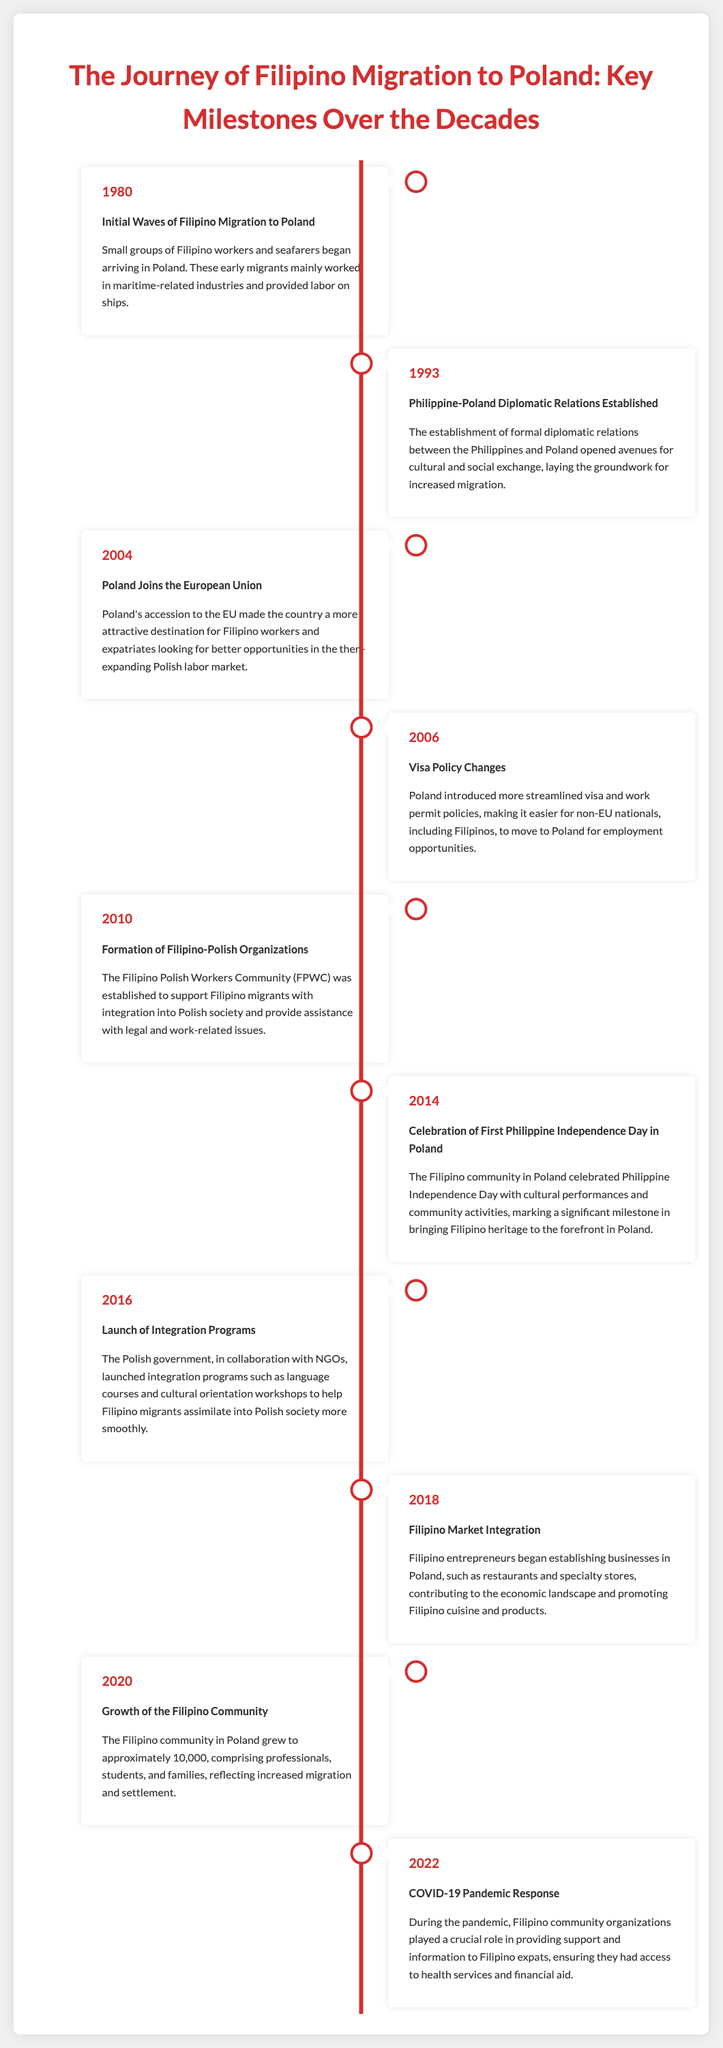What year did the initial waves of Filipino migration to Poland begin? The document states that small groups of Filipino workers began arriving in Poland in 1980, marking the start of migration.
Answer: 1980 What organization was established in 2010 to support Filipino migrants? The document mentions the formation of the Filipino Polish Workers Community (FPWC) in 2010 to assist newcomers with integration and legal matters.
Answer: Filipino Polish Workers Community (FPWC) How many Filipino community members were there in Poland by 2020? According to the document, the Filipino community grew to approximately 10,000 members by the year 2020.
Answer: 10,000 What significant event occurred in 2014 related to Filipino culture in Poland? The document highlights the celebration of the first Philippine Independence Day in Poland in 2014 as a key cultural milestone for the Filipino community.
Answer: Celebration of First Philippine Independence Day What key change in visa policy occurred in 2006? The document notes that in 2006, Poland introduced more streamlined visa and work permit policies to facilitate migration for non-EU nationals, including Filipinos.
Answer: Streamlined visa and work permit policies What role did community organizations play during the COVID-19 pandemic? The document indicates that Filipino community organizations provided crucial support and information to expats during the pandemic, which included access to health services and financial aid.
Answer: Support and information In what year did Poland join the European Union? The document states that Poland joined the European Union in 2004, which was a pivotal moment for attracting Filipino workers.
Answer: 2004 Which year marked the launch of integration programs for Filipino migrants? The document reveals that integration programs aimed at helping Filipino migrants assimilate into Polish society were launched in 2016.
Answer: 2016 